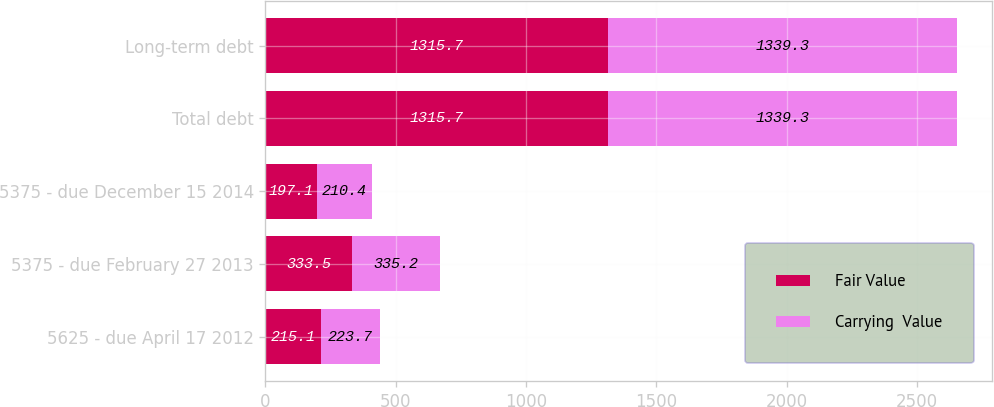<chart> <loc_0><loc_0><loc_500><loc_500><stacked_bar_chart><ecel><fcel>5625 - due April 17 2012<fcel>5375 - due February 27 2013<fcel>5375 - due December 15 2014<fcel>Total debt<fcel>Long-term debt<nl><fcel>Fair Value<fcel>215.1<fcel>333.5<fcel>197.1<fcel>1315.7<fcel>1315.7<nl><fcel>Carrying  Value<fcel>223.7<fcel>335.2<fcel>210.4<fcel>1339.3<fcel>1339.3<nl></chart> 